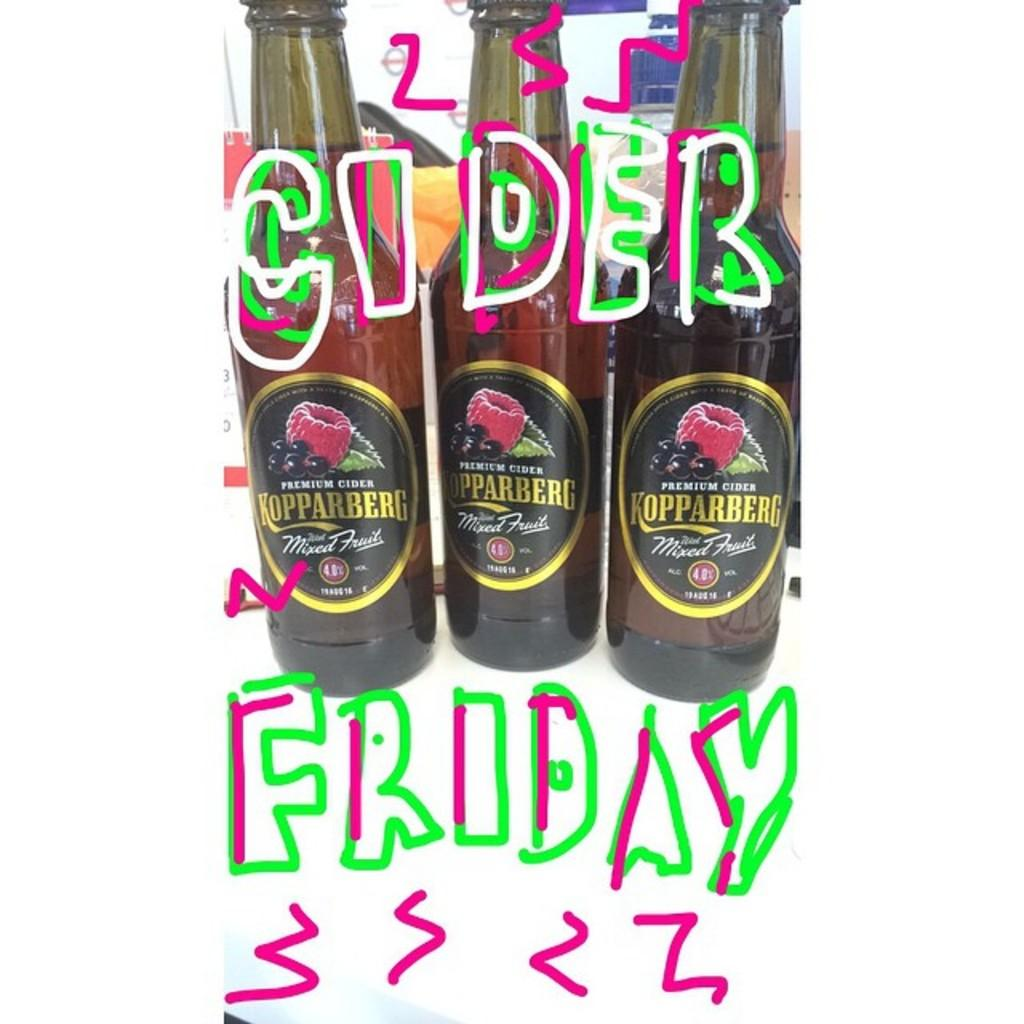<image>
Present a compact description of the photo's key features. Three bottles of Kopparberg cider are grouped together. 